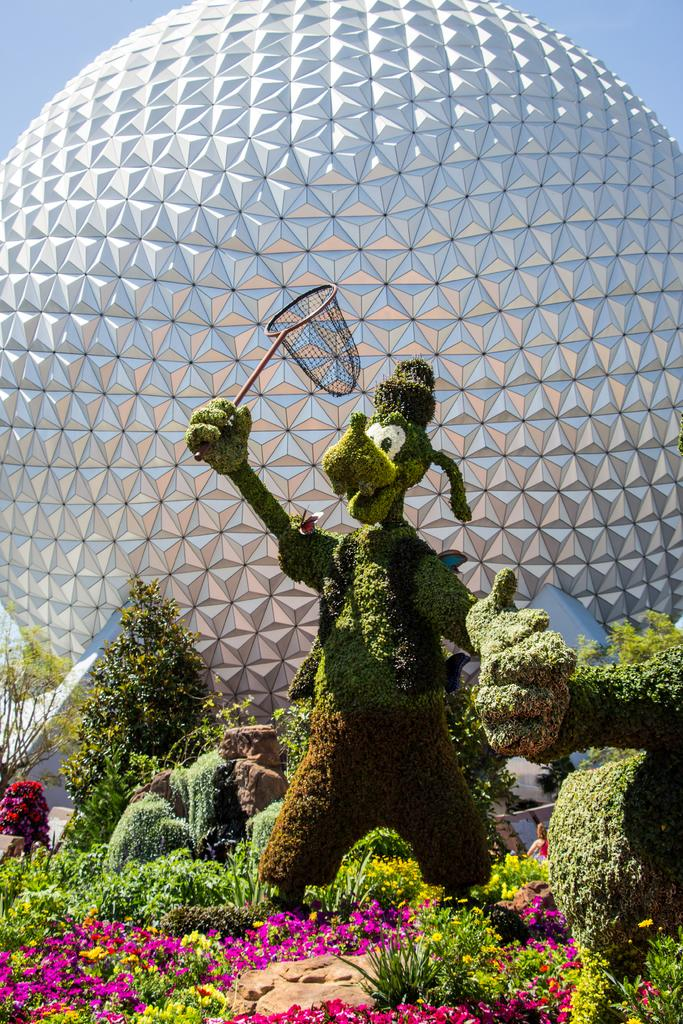What type of plant is depicted in the image? There is a plant in the shape of a cartoon in the image. What other types of plants and flowers can be seen in the image? There are different types of plants and flowers in the image. What object is located at the back of the image? There is a ball at the back of the image. What is visible at the top of the image? The sky is visible at the top of the image. What year is depicted in the image? The image does not depict a specific year; it features plants, flowers, and a ball. Can you see a lake in the image? There is no lake present in the image. 